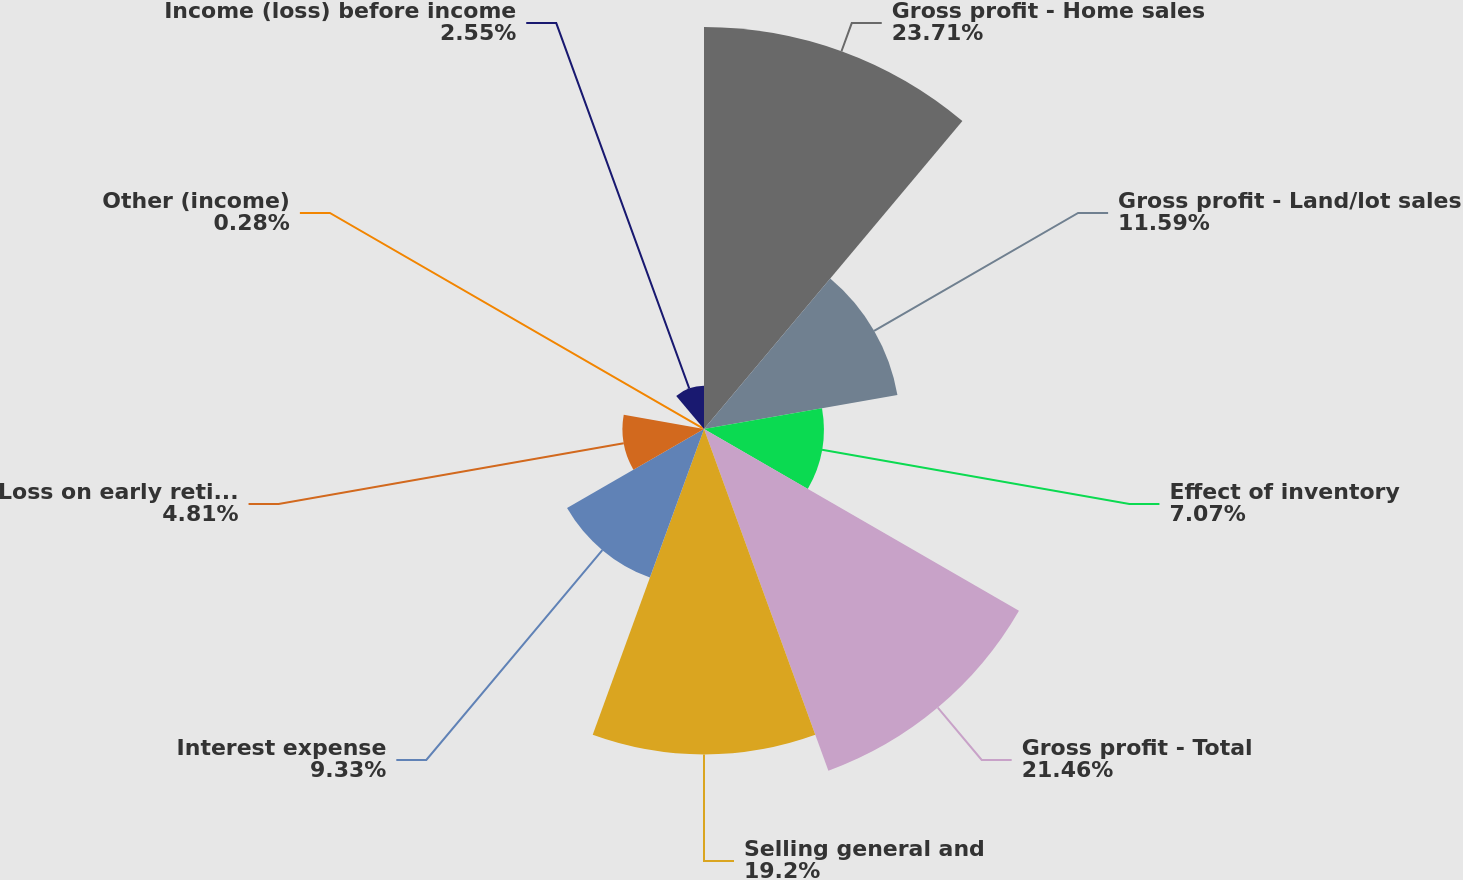Convert chart to OTSL. <chart><loc_0><loc_0><loc_500><loc_500><pie_chart><fcel>Gross profit - Home sales<fcel>Gross profit - Land/lot sales<fcel>Effect of inventory<fcel>Gross profit - Total<fcel>Selling general and<fcel>Interest expense<fcel>Loss on early retirement of<fcel>Other (income)<fcel>Income (loss) before income<nl><fcel>23.72%<fcel>11.59%<fcel>7.07%<fcel>21.46%<fcel>19.2%<fcel>9.33%<fcel>4.81%<fcel>0.28%<fcel>2.55%<nl></chart> 